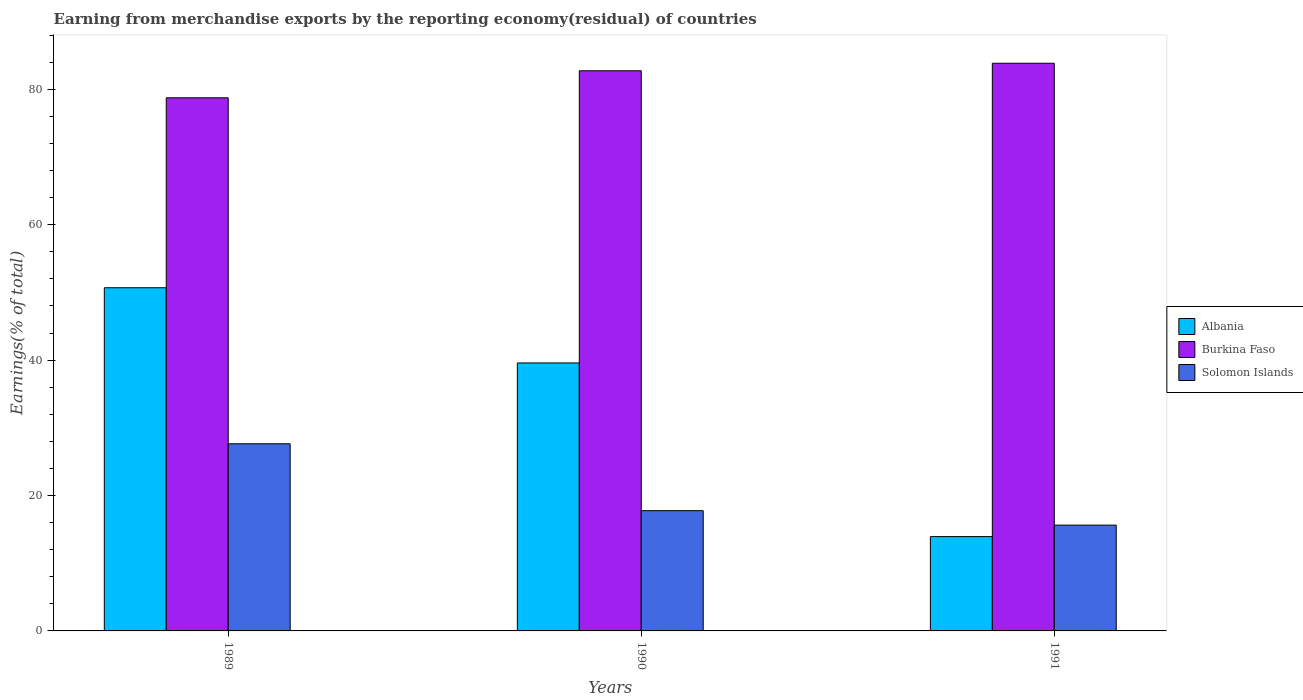How many groups of bars are there?
Keep it short and to the point. 3. Are the number of bars on each tick of the X-axis equal?
Give a very brief answer. Yes. How many bars are there on the 3rd tick from the left?
Your response must be concise. 3. How many bars are there on the 2nd tick from the right?
Offer a terse response. 3. What is the label of the 2nd group of bars from the left?
Your answer should be very brief. 1990. In how many cases, is the number of bars for a given year not equal to the number of legend labels?
Make the answer very short. 0. What is the percentage of amount earned from merchandise exports in Solomon Islands in 1989?
Your answer should be very brief. 27.64. Across all years, what is the maximum percentage of amount earned from merchandise exports in Albania?
Give a very brief answer. 50.69. Across all years, what is the minimum percentage of amount earned from merchandise exports in Albania?
Make the answer very short. 13.93. In which year was the percentage of amount earned from merchandise exports in Albania maximum?
Your response must be concise. 1989. What is the total percentage of amount earned from merchandise exports in Albania in the graph?
Offer a very short reply. 104.21. What is the difference between the percentage of amount earned from merchandise exports in Albania in 1989 and that in 1991?
Your response must be concise. 36.76. What is the difference between the percentage of amount earned from merchandise exports in Solomon Islands in 1989 and the percentage of amount earned from merchandise exports in Burkina Faso in 1991?
Make the answer very short. -56.21. What is the average percentage of amount earned from merchandise exports in Burkina Faso per year?
Provide a short and direct response. 81.78. In the year 1991, what is the difference between the percentage of amount earned from merchandise exports in Albania and percentage of amount earned from merchandise exports in Solomon Islands?
Keep it short and to the point. -1.7. What is the ratio of the percentage of amount earned from merchandise exports in Albania in 1989 to that in 1990?
Your answer should be very brief. 1.28. Is the difference between the percentage of amount earned from merchandise exports in Albania in 1990 and 1991 greater than the difference between the percentage of amount earned from merchandise exports in Solomon Islands in 1990 and 1991?
Offer a very short reply. Yes. What is the difference between the highest and the second highest percentage of amount earned from merchandise exports in Solomon Islands?
Keep it short and to the point. 9.88. What is the difference between the highest and the lowest percentage of amount earned from merchandise exports in Burkina Faso?
Your answer should be compact. 5.1. In how many years, is the percentage of amount earned from merchandise exports in Solomon Islands greater than the average percentage of amount earned from merchandise exports in Solomon Islands taken over all years?
Provide a succinct answer. 1. Is the sum of the percentage of amount earned from merchandise exports in Burkina Faso in 1989 and 1990 greater than the maximum percentage of amount earned from merchandise exports in Albania across all years?
Offer a very short reply. Yes. What does the 2nd bar from the left in 1991 represents?
Your response must be concise. Burkina Faso. What does the 1st bar from the right in 1990 represents?
Offer a very short reply. Solomon Islands. Is it the case that in every year, the sum of the percentage of amount earned from merchandise exports in Solomon Islands and percentage of amount earned from merchandise exports in Burkina Faso is greater than the percentage of amount earned from merchandise exports in Albania?
Ensure brevity in your answer.  Yes. What is the difference between two consecutive major ticks on the Y-axis?
Your answer should be compact. 20. How many legend labels are there?
Give a very brief answer. 3. How are the legend labels stacked?
Your answer should be very brief. Vertical. What is the title of the graph?
Your answer should be very brief. Earning from merchandise exports by the reporting economy(residual) of countries. What is the label or title of the Y-axis?
Ensure brevity in your answer.  Earnings(% of total). What is the Earnings(% of total) in Albania in 1989?
Give a very brief answer. 50.69. What is the Earnings(% of total) of Burkina Faso in 1989?
Your response must be concise. 78.75. What is the Earnings(% of total) of Solomon Islands in 1989?
Ensure brevity in your answer.  27.64. What is the Earnings(% of total) of Albania in 1990?
Keep it short and to the point. 39.58. What is the Earnings(% of total) of Burkina Faso in 1990?
Your answer should be very brief. 82.74. What is the Earnings(% of total) of Solomon Islands in 1990?
Offer a terse response. 17.76. What is the Earnings(% of total) in Albania in 1991?
Provide a succinct answer. 13.93. What is the Earnings(% of total) in Burkina Faso in 1991?
Your answer should be very brief. 83.85. What is the Earnings(% of total) of Solomon Islands in 1991?
Your response must be concise. 15.63. Across all years, what is the maximum Earnings(% of total) of Albania?
Your answer should be compact. 50.69. Across all years, what is the maximum Earnings(% of total) of Burkina Faso?
Give a very brief answer. 83.85. Across all years, what is the maximum Earnings(% of total) in Solomon Islands?
Keep it short and to the point. 27.64. Across all years, what is the minimum Earnings(% of total) in Albania?
Keep it short and to the point. 13.93. Across all years, what is the minimum Earnings(% of total) in Burkina Faso?
Offer a terse response. 78.75. Across all years, what is the minimum Earnings(% of total) in Solomon Islands?
Make the answer very short. 15.63. What is the total Earnings(% of total) of Albania in the graph?
Provide a succinct answer. 104.21. What is the total Earnings(% of total) in Burkina Faso in the graph?
Provide a succinct answer. 245.33. What is the total Earnings(% of total) in Solomon Islands in the graph?
Ensure brevity in your answer.  61.03. What is the difference between the Earnings(% of total) in Albania in 1989 and that in 1990?
Your answer should be very brief. 11.11. What is the difference between the Earnings(% of total) in Burkina Faso in 1989 and that in 1990?
Provide a succinct answer. -3.99. What is the difference between the Earnings(% of total) in Solomon Islands in 1989 and that in 1990?
Provide a short and direct response. 9.88. What is the difference between the Earnings(% of total) in Albania in 1989 and that in 1991?
Ensure brevity in your answer.  36.76. What is the difference between the Earnings(% of total) of Burkina Faso in 1989 and that in 1991?
Your response must be concise. -5.1. What is the difference between the Earnings(% of total) of Solomon Islands in 1989 and that in 1991?
Your answer should be compact. 12.02. What is the difference between the Earnings(% of total) in Albania in 1990 and that in 1991?
Give a very brief answer. 25.65. What is the difference between the Earnings(% of total) in Burkina Faso in 1990 and that in 1991?
Make the answer very short. -1.11. What is the difference between the Earnings(% of total) of Solomon Islands in 1990 and that in 1991?
Your answer should be very brief. 2.14. What is the difference between the Earnings(% of total) in Albania in 1989 and the Earnings(% of total) in Burkina Faso in 1990?
Provide a short and direct response. -32.05. What is the difference between the Earnings(% of total) in Albania in 1989 and the Earnings(% of total) in Solomon Islands in 1990?
Keep it short and to the point. 32.93. What is the difference between the Earnings(% of total) of Burkina Faso in 1989 and the Earnings(% of total) of Solomon Islands in 1990?
Keep it short and to the point. 60.98. What is the difference between the Earnings(% of total) of Albania in 1989 and the Earnings(% of total) of Burkina Faso in 1991?
Offer a very short reply. -33.16. What is the difference between the Earnings(% of total) in Albania in 1989 and the Earnings(% of total) in Solomon Islands in 1991?
Offer a terse response. 35.06. What is the difference between the Earnings(% of total) in Burkina Faso in 1989 and the Earnings(% of total) in Solomon Islands in 1991?
Make the answer very short. 63.12. What is the difference between the Earnings(% of total) of Albania in 1990 and the Earnings(% of total) of Burkina Faso in 1991?
Provide a short and direct response. -44.27. What is the difference between the Earnings(% of total) of Albania in 1990 and the Earnings(% of total) of Solomon Islands in 1991?
Provide a succinct answer. 23.96. What is the difference between the Earnings(% of total) of Burkina Faso in 1990 and the Earnings(% of total) of Solomon Islands in 1991?
Your answer should be compact. 67.11. What is the average Earnings(% of total) of Albania per year?
Offer a very short reply. 34.74. What is the average Earnings(% of total) of Burkina Faso per year?
Make the answer very short. 81.78. What is the average Earnings(% of total) of Solomon Islands per year?
Offer a very short reply. 20.34. In the year 1989, what is the difference between the Earnings(% of total) in Albania and Earnings(% of total) in Burkina Faso?
Make the answer very short. -28.06. In the year 1989, what is the difference between the Earnings(% of total) in Albania and Earnings(% of total) in Solomon Islands?
Provide a succinct answer. 23.05. In the year 1989, what is the difference between the Earnings(% of total) of Burkina Faso and Earnings(% of total) of Solomon Islands?
Offer a terse response. 51.1. In the year 1990, what is the difference between the Earnings(% of total) in Albania and Earnings(% of total) in Burkina Faso?
Keep it short and to the point. -43.15. In the year 1990, what is the difference between the Earnings(% of total) in Albania and Earnings(% of total) in Solomon Islands?
Your answer should be very brief. 21.82. In the year 1990, what is the difference between the Earnings(% of total) of Burkina Faso and Earnings(% of total) of Solomon Islands?
Give a very brief answer. 64.97. In the year 1991, what is the difference between the Earnings(% of total) in Albania and Earnings(% of total) in Burkina Faso?
Keep it short and to the point. -69.92. In the year 1991, what is the difference between the Earnings(% of total) of Albania and Earnings(% of total) of Solomon Islands?
Offer a terse response. -1.7. In the year 1991, what is the difference between the Earnings(% of total) of Burkina Faso and Earnings(% of total) of Solomon Islands?
Keep it short and to the point. 68.22. What is the ratio of the Earnings(% of total) in Albania in 1989 to that in 1990?
Offer a terse response. 1.28. What is the ratio of the Earnings(% of total) of Burkina Faso in 1989 to that in 1990?
Your answer should be very brief. 0.95. What is the ratio of the Earnings(% of total) of Solomon Islands in 1989 to that in 1990?
Give a very brief answer. 1.56. What is the ratio of the Earnings(% of total) of Albania in 1989 to that in 1991?
Keep it short and to the point. 3.64. What is the ratio of the Earnings(% of total) in Burkina Faso in 1989 to that in 1991?
Offer a very short reply. 0.94. What is the ratio of the Earnings(% of total) of Solomon Islands in 1989 to that in 1991?
Provide a succinct answer. 1.77. What is the ratio of the Earnings(% of total) in Albania in 1990 to that in 1991?
Make the answer very short. 2.84. What is the ratio of the Earnings(% of total) in Burkina Faso in 1990 to that in 1991?
Provide a succinct answer. 0.99. What is the ratio of the Earnings(% of total) in Solomon Islands in 1990 to that in 1991?
Your response must be concise. 1.14. What is the difference between the highest and the second highest Earnings(% of total) of Albania?
Offer a terse response. 11.11. What is the difference between the highest and the second highest Earnings(% of total) in Burkina Faso?
Ensure brevity in your answer.  1.11. What is the difference between the highest and the second highest Earnings(% of total) in Solomon Islands?
Make the answer very short. 9.88. What is the difference between the highest and the lowest Earnings(% of total) of Albania?
Your response must be concise. 36.76. What is the difference between the highest and the lowest Earnings(% of total) in Burkina Faso?
Provide a succinct answer. 5.1. What is the difference between the highest and the lowest Earnings(% of total) in Solomon Islands?
Keep it short and to the point. 12.02. 